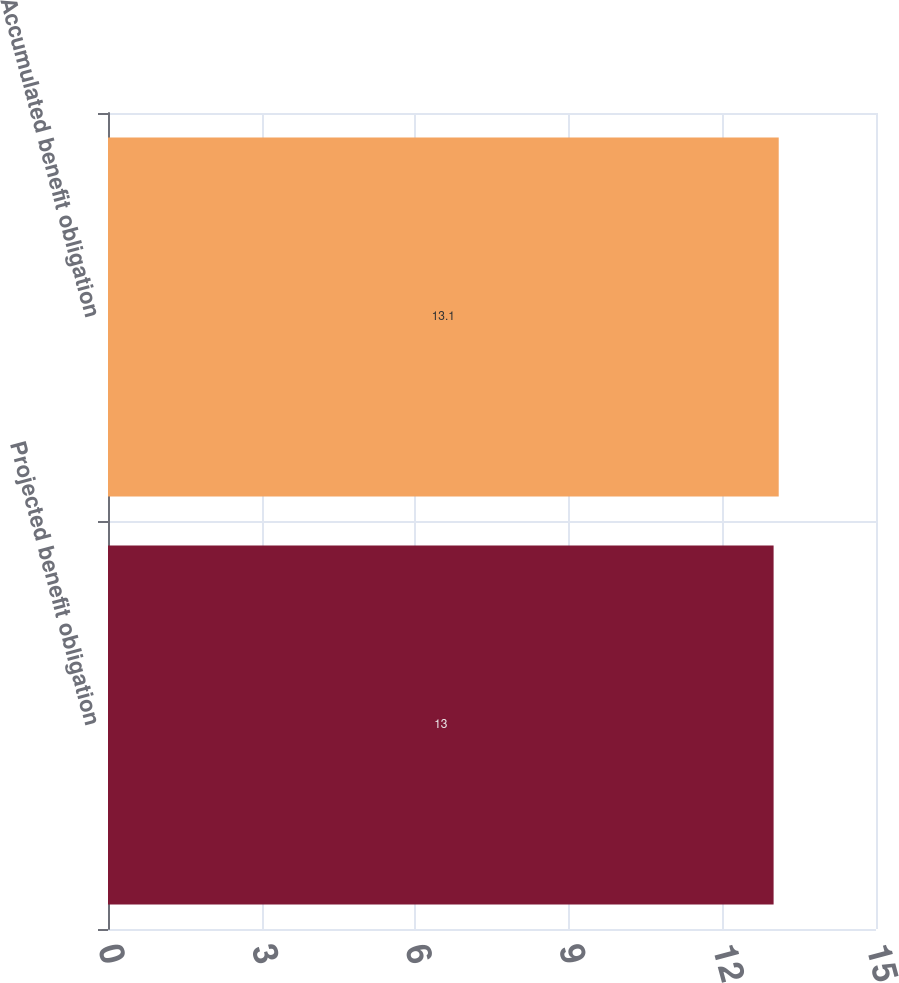Convert chart to OTSL. <chart><loc_0><loc_0><loc_500><loc_500><bar_chart><fcel>Projected benefit obligation<fcel>Accumulated benefit obligation<nl><fcel>13<fcel>13.1<nl></chart> 